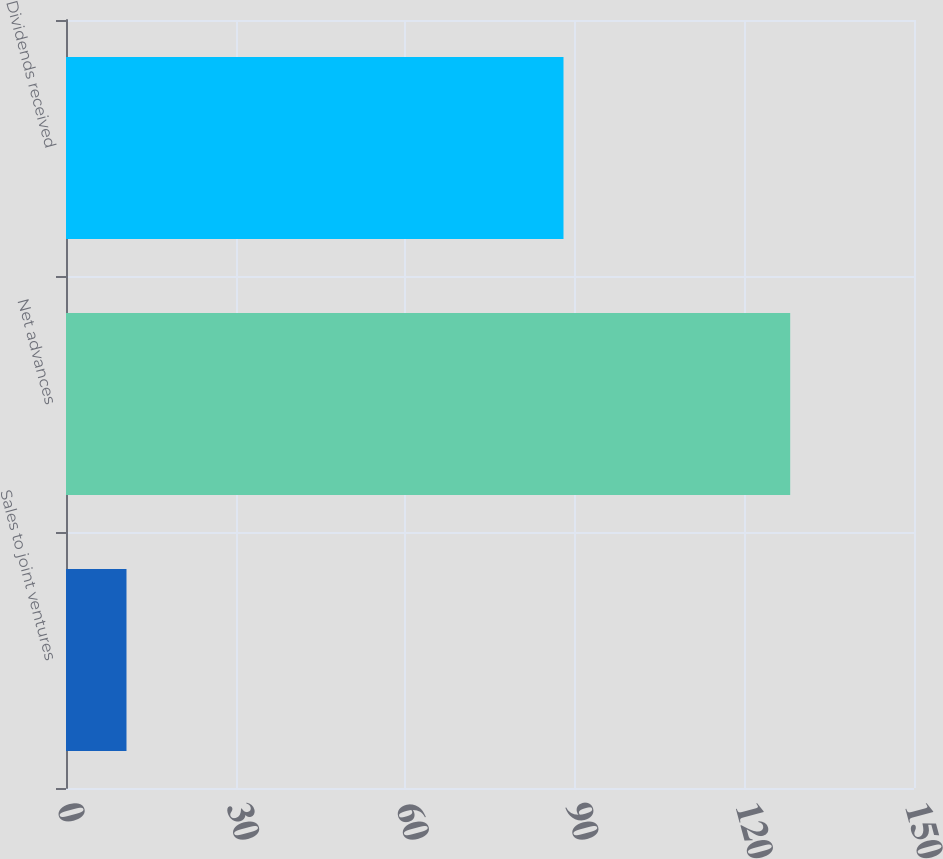<chart> <loc_0><loc_0><loc_500><loc_500><bar_chart><fcel>Sales to joint ventures<fcel>Net advances<fcel>Dividends received<nl><fcel>10.7<fcel>128.1<fcel>88<nl></chart> 